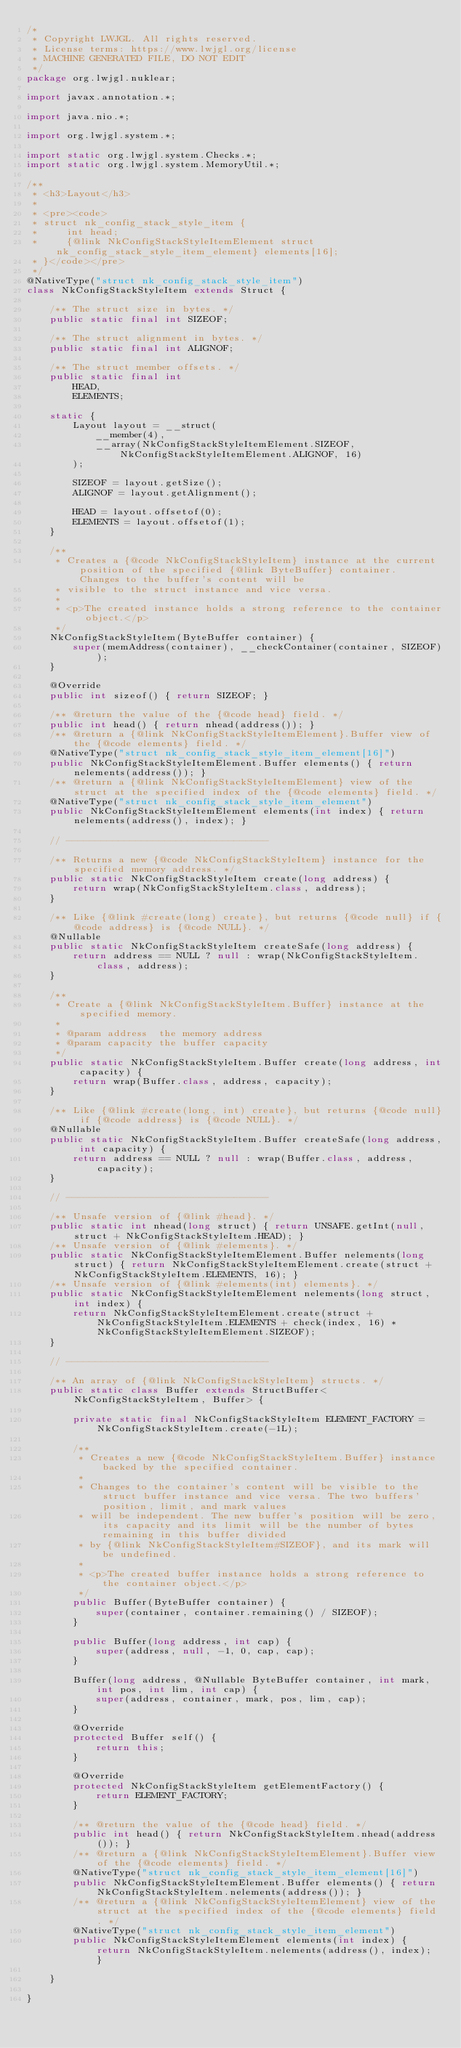<code> <loc_0><loc_0><loc_500><loc_500><_Java_>/*
 * Copyright LWJGL. All rights reserved.
 * License terms: https://www.lwjgl.org/license
 * MACHINE GENERATED FILE, DO NOT EDIT
 */
package org.lwjgl.nuklear;

import javax.annotation.*;

import java.nio.*;

import org.lwjgl.system.*;

import static org.lwjgl.system.Checks.*;
import static org.lwjgl.system.MemoryUtil.*;

/**
 * <h3>Layout</h3>
 * 
 * <pre><code>
 * struct nk_config_stack_style_item {
 *     int head;
 *     {@link NkConfigStackStyleItemElement struct nk_config_stack_style_item_element} elements[16];
 * }</code></pre>
 */
@NativeType("struct nk_config_stack_style_item")
class NkConfigStackStyleItem extends Struct {

    /** The struct size in bytes. */
    public static final int SIZEOF;

    /** The struct alignment in bytes. */
    public static final int ALIGNOF;

    /** The struct member offsets. */
    public static final int
        HEAD,
        ELEMENTS;

    static {
        Layout layout = __struct(
            __member(4),
            __array(NkConfigStackStyleItemElement.SIZEOF, NkConfigStackStyleItemElement.ALIGNOF, 16)
        );

        SIZEOF = layout.getSize();
        ALIGNOF = layout.getAlignment();

        HEAD = layout.offsetof(0);
        ELEMENTS = layout.offsetof(1);
    }

    /**
     * Creates a {@code NkConfigStackStyleItem} instance at the current position of the specified {@link ByteBuffer} container. Changes to the buffer's content will be
     * visible to the struct instance and vice versa.
     *
     * <p>The created instance holds a strong reference to the container object.</p>
     */
    NkConfigStackStyleItem(ByteBuffer container) {
        super(memAddress(container), __checkContainer(container, SIZEOF));
    }

    @Override
    public int sizeof() { return SIZEOF; }

    /** @return the value of the {@code head} field. */
    public int head() { return nhead(address()); }
    /** @return a {@link NkConfigStackStyleItemElement}.Buffer view of the {@code elements} field. */
    @NativeType("struct nk_config_stack_style_item_element[16]")
    public NkConfigStackStyleItemElement.Buffer elements() { return nelements(address()); }
    /** @return a {@link NkConfigStackStyleItemElement} view of the struct at the specified index of the {@code elements} field. */
    @NativeType("struct nk_config_stack_style_item_element")
    public NkConfigStackStyleItemElement elements(int index) { return nelements(address(), index); }

    // -----------------------------------

    /** Returns a new {@code NkConfigStackStyleItem} instance for the specified memory address. */
    public static NkConfigStackStyleItem create(long address) {
        return wrap(NkConfigStackStyleItem.class, address);
    }

    /** Like {@link #create(long) create}, but returns {@code null} if {@code address} is {@code NULL}. */
    @Nullable
    public static NkConfigStackStyleItem createSafe(long address) {
        return address == NULL ? null : wrap(NkConfigStackStyleItem.class, address);
    }

    /**
     * Create a {@link NkConfigStackStyleItem.Buffer} instance at the specified memory.
     *
     * @param address  the memory address
     * @param capacity the buffer capacity
     */
    public static NkConfigStackStyleItem.Buffer create(long address, int capacity) {
        return wrap(Buffer.class, address, capacity);
    }

    /** Like {@link #create(long, int) create}, but returns {@code null} if {@code address} is {@code NULL}. */
    @Nullable
    public static NkConfigStackStyleItem.Buffer createSafe(long address, int capacity) {
        return address == NULL ? null : wrap(Buffer.class, address, capacity);
    }

    // -----------------------------------

    /** Unsafe version of {@link #head}. */
    public static int nhead(long struct) { return UNSAFE.getInt(null, struct + NkConfigStackStyleItem.HEAD); }
    /** Unsafe version of {@link #elements}. */
    public static NkConfigStackStyleItemElement.Buffer nelements(long struct) { return NkConfigStackStyleItemElement.create(struct + NkConfigStackStyleItem.ELEMENTS, 16); }
    /** Unsafe version of {@link #elements(int) elements}. */
    public static NkConfigStackStyleItemElement nelements(long struct, int index) {
        return NkConfigStackStyleItemElement.create(struct + NkConfigStackStyleItem.ELEMENTS + check(index, 16) * NkConfigStackStyleItemElement.SIZEOF);
    }

    // -----------------------------------

    /** An array of {@link NkConfigStackStyleItem} structs. */
    public static class Buffer extends StructBuffer<NkConfigStackStyleItem, Buffer> {

        private static final NkConfigStackStyleItem ELEMENT_FACTORY = NkConfigStackStyleItem.create(-1L);

        /**
         * Creates a new {@code NkConfigStackStyleItem.Buffer} instance backed by the specified container.
         *
         * Changes to the container's content will be visible to the struct buffer instance and vice versa. The two buffers' position, limit, and mark values
         * will be independent. The new buffer's position will be zero, its capacity and its limit will be the number of bytes remaining in this buffer divided
         * by {@link NkConfigStackStyleItem#SIZEOF}, and its mark will be undefined.
         *
         * <p>The created buffer instance holds a strong reference to the container object.</p>
         */
        public Buffer(ByteBuffer container) {
            super(container, container.remaining() / SIZEOF);
        }

        public Buffer(long address, int cap) {
            super(address, null, -1, 0, cap, cap);
        }

        Buffer(long address, @Nullable ByteBuffer container, int mark, int pos, int lim, int cap) {
            super(address, container, mark, pos, lim, cap);
        }

        @Override
        protected Buffer self() {
            return this;
        }

        @Override
        protected NkConfigStackStyleItem getElementFactory() {
            return ELEMENT_FACTORY;
        }

        /** @return the value of the {@code head} field. */
        public int head() { return NkConfigStackStyleItem.nhead(address()); }
        /** @return a {@link NkConfigStackStyleItemElement}.Buffer view of the {@code elements} field. */
        @NativeType("struct nk_config_stack_style_item_element[16]")
        public NkConfigStackStyleItemElement.Buffer elements() { return NkConfigStackStyleItem.nelements(address()); }
        /** @return a {@link NkConfigStackStyleItemElement} view of the struct at the specified index of the {@code elements} field. */
        @NativeType("struct nk_config_stack_style_item_element")
        public NkConfigStackStyleItemElement elements(int index) { return NkConfigStackStyleItem.nelements(address(), index); }

    }

}</code> 